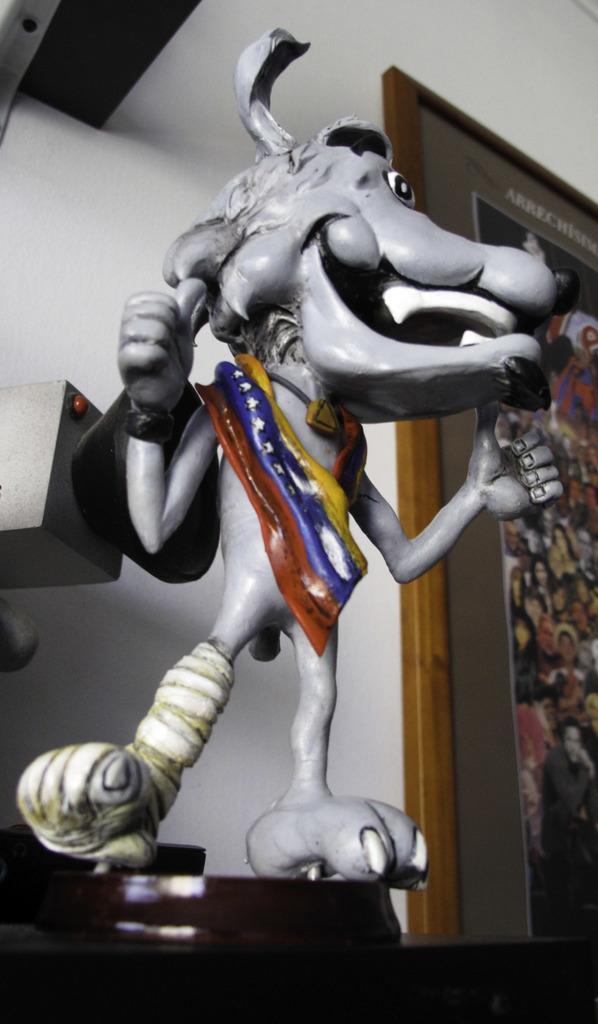How would you summarize this image in a sentence or two? In the center of the image there is a depiction of a animal on the table. In the background of the image there is a wall. There is a photo frame. To the left side of the image there is a object on the wall. 